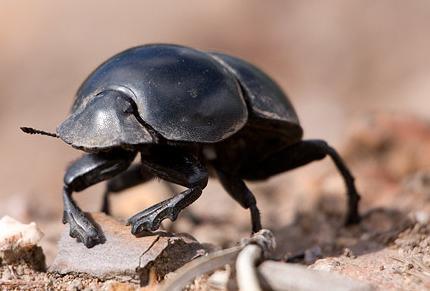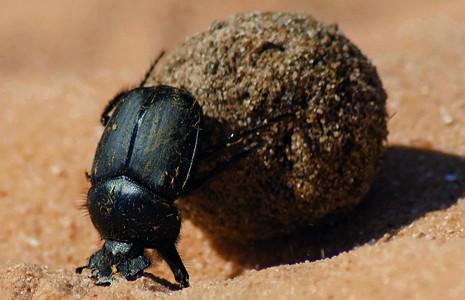The first image is the image on the left, the second image is the image on the right. Evaluate the accuracy of this statement regarding the images: "There is no dung in one image.". Is it true? Answer yes or no. Yes. The first image is the image on the left, the second image is the image on the right. Considering the images on both sides, is "Each image shows exactly one dark beetle in contact with one brown ball." valid? Answer yes or no. No. 